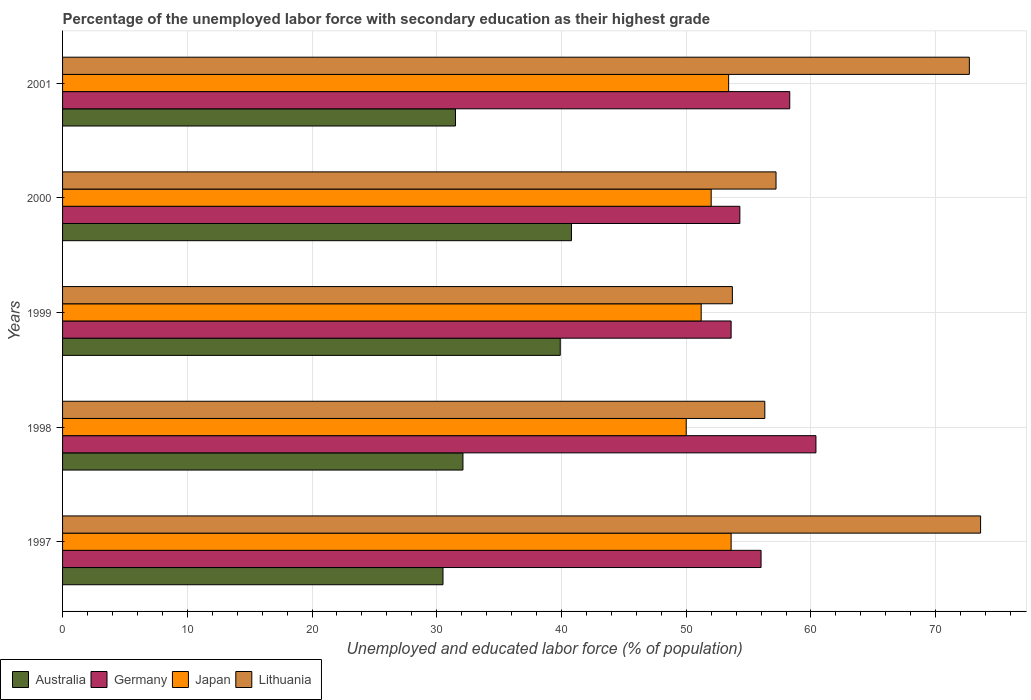How many different coloured bars are there?
Offer a very short reply. 4. How many groups of bars are there?
Keep it short and to the point. 5. Are the number of bars per tick equal to the number of legend labels?
Offer a terse response. Yes. How many bars are there on the 5th tick from the top?
Ensure brevity in your answer.  4. How many bars are there on the 4th tick from the bottom?
Provide a short and direct response. 4. What is the label of the 4th group of bars from the top?
Provide a succinct answer. 1998. In how many cases, is the number of bars for a given year not equal to the number of legend labels?
Keep it short and to the point. 0. What is the percentage of the unemployed labor force with secondary education in Germany in 1999?
Your answer should be compact. 53.6. Across all years, what is the maximum percentage of the unemployed labor force with secondary education in Germany?
Offer a terse response. 60.4. Across all years, what is the minimum percentage of the unemployed labor force with secondary education in Germany?
Your answer should be very brief. 53.6. In which year was the percentage of the unemployed labor force with secondary education in Japan minimum?
Your answer should be compact. 1998. What is the total percentage of the unemployed labor force with secondary education in Japan in the graph?
Your answer should be compact. 260.2. What is the difference between the percentage of the unemployed labor force with secondary education in Germany in 1997 and that in 2000?
Your response must be concise. 1.7. What is the difference between the percentage of the unemployed labor force with secondary education in Germany in 1998 and the percentage of the unemployed labor force with secondary education in Japan in 1999?
Make the answer very short. 9.2. What is the average percentage of the unemployed labor force with secondary education in Japan per year?
Give a very brief answer. 52.04. In the year 2001, what is the difference between the percentage of the unemployed labor force with secondary education in Japan and percentage of the unemployed labor force with secondary education in Lithuania?
Keep it short and to the point. -19.3. What is the ratio of the percentage of the unemployed labor force with secondary education in Japan in 1997 to that in 1998?
Your answer should be very brief. 1.07. Is the difference between the percentage of the unemployed labor force with secondary education in Japan in 1999 and 2001 greater than the difference between the percentage of the unemployed labor force with secondary education in Lithuania in 1999 and 2001?
Offer a terse response. Yes. What is the difference between the highest and the second highest percentage of the unemployed labor force with secondary education in Germany?
Give a very brief answer. 2.1. What is the difference between the highest and the lowest percentage of the unemployed labor force with secondary education in Japan?
Offer a very short reply. 3.6. Is it the case that in every year, the sum of the percentage of the unemployed labor force with secondary education in Japan and percentage of the unemployed labor force with secondary education in Germany is greater than the sum of percentage of the unemployed labor force with secondary education in Australia and percentage of the unemployed labor force with secondary education in Lithuania?
Offer a very short reply. No. What does the 3rd bar from the bottom in 2001 represents?
Ensure brevity in your answer.  Japan. How many bars are there?
Your response must be concise. 20. How many years are there in the graph?
Your answer should be very brief. 5. What is the difference between two consecutive major ticks on the X-axis?
Give a very brief answer. 10. Are the values on the major ticks of X-axis written in scientific E-notation?
Provide a short and direct response. No. Does the graph contain any zero values?
Offer a very short reply. No. Does the graph contain grids?
Offer a very short reply. Yes. How many legend labels are there?
Offer a very short reply. 4. How are the legend labels stacked?
Keep it short and to the point. Horizontal. What is the title of the graph?
Provide a short and direct response. Percentage of the unemployed labor force with secondary education as their highest grade. Does "Gabon" appear as one of the legend labels in the graph?
Provide a succinct answer. No. What is the label or title of the X-axis?
Offer a very short reply. Unemployed and educated labor force (% of population). What is the label or title of the Y-axis?
Your answer should be compact. Years. What is the Unemployed and educated labor force (% of population) of Australia in 1997?
Your answer should be compact. 30.5. What is the Unemployed and educated labor force (% of population) in Japan in 1997?
Provide a succinct answer. 53.6. What is the Unemployed and educated labor force (% of population) of Lithuania in 1997?
Ensure brevity in your answer.  73.6. What is the Unemployed and educated labor force (% of population) in Australia in 1998?
Your answer should be compact. 32.1. What is the Unemployed and educated labor force (% of population) in Germany in 1998?
Provide a succinct answer. 60.4. What is the Unemployed and educated labor force (% of population) in Japan in 1998?
Ensure brevity in your answer.  50. What is the Unemployed and educated labor force (% of population) in Lithuania in 1998?
Your answer should be very brief. 56.3. What is the Unemployed and educated labor force (% of population) of Australia in 1999?
Offer a very short reply. 39.9. What is the Unemployed and educated labor force (% of population) in Germany in 1999?
Your answer should be very brief. 53.6. What is the Unemployed and educated labor force (% of population) of Japan in 1999?
Your answer should be very brief. 51.2. What is the Unemployed and educated labor force (% of population) of Lithuania in 1999?
Offer a terse response. 53.7. What is the Unemployed and educated labor force (% of population) of Australia in 2000?
Offer a terse response. 40.8. What is the Unemployed and educated labor force (% of population) of Germany in 2000?
Offer a terse response. 54.3. What is the Unemployed and educated labor force (% of population) in Lithuania in 2000?
Make the answer very short. 57.2. What is the Unemployed and educated labor force (% of population) in Australia in 2001?
Ensure brevity in your answer.  31.5. What is the Unemployed and educated labor force (% of population) in Germany in 2001?
Offer a terse response. 58.3. What is the Unemployed and educated labor force (% of population) of Japan in 2001?
Provide a succinct answer. 53.4. What is the Unemployed and educated labor force (% of population) in Lithuania in 2001?
Ensure brevity in your answer.  72.7. Across all years, what is the maximum Unemployed and educated labor force (% of population) of Australia?
Your response must be concise. 40.8. Across all years, what is the maximum Unemployed and educated labor force (% of population) of Germany?
Provide a short and direct response. 60.4. Across all years, what is the maximum Unemployed and educated labor force (% of population) in Japan?
Offer a terse response. 53.6. Across all years, what is the maximum Unemployed and educated labor force (% of population) of Lithuania?
Offer a very short reply. 73.6. Across all years, what is the minimum Unemployed and educated labor force (% of population) of Australia?
Your answer should be compact. 30.5. Across all years, what is the minimum Unemployed and educated labor force (% of population) of Germany?
Give a very brief answer. 53.6. Across all years, what is the minimum Unemployed and educated labor force (% of population) in Lithuania?
Make the answer very short. 53.7. What is the total Unemployed and educated labor force (% of population) in Australia in the graph?
Offer a very short reply. 174.8. What is the total Unemployed and educated labor force (% of population) of Germany in the graph?
Keep it short and to the point. 282.6. What is the total Unemployed and educated labor force (% of population) in Japan in the graph?
Your answer should be compact. 260.2. What is the total Unemployed and educated labor force (% of population) of Lithuania in the graph?
Your answer should be compact. 313.5. What is the difference between the Unemployed and educated labor force (% of population) in Australia in 1997 and that in 1999?
Your answer should be compact. -9.4. What is the difference between the Unemployed and educated labor force (% of population) of Germany in 1997 and that in 1999?
Provide a short and direct response. 2.4. What is the difference between the Unemployed and educated labor force (% of population) in Lithuania in 1997 and that in 1999?
Your answer should be compact. 19.9. What is the difference between the Unemployed and educated labor force (% of population) of Germany in 1997 and that in 2000?
Your response must be concise. 1.7. What is the difference between the Unemployed and educated labor force (% of population) in Japan in 1997 and that in 2001?
Your response must be concise. 0.2. What is the difference between the Unemployed and educated labor force (% of population) of Australia in 1998 and that in 1999?
Offer a very short reply. -7.8. What is the difference between the Unemployed and educated labor force (% of population) of Germany in 1998 and that in 1999?
Offer a terse response. 6.8. What is the difference between the Unemployed and educated labor force (% of population) in Lithuania in 1998 and that in 1999?
Make the answer very short. 2.6. What is the difference between the Unemployed and educated labor force (% of population) of Germany in 1998 and that in 2000?
Provide a succinct answer. 6.1. What is the difference between the Unemployed and educated labor force (% of population) in Lithuania in 1998 and that in 2001?
Your response must be concise. -16.4. What is the difference between the Unemployed and educated labor force (% of population) of Germany in 1999 and that in 2000?
Offer a terse response. -0.7. What is the difference between the Unemployed and educated labor force (% of population) of Japan in 1999 and that in 2000?
Your response must be concise. -0.8. What is the difference between the Unemployed and educated labor force (% of population) of Lithuania in 1999 and that in 2000?
Offer a terse response. -3.5. What is the difference between the Unemployed and educated labor force (% of population) in Lithuania in 2000 and that in 2001?
Your response must be concise. -15.5. What is the difference between the Unemployed and educated labor force (% of population) in Australia in 1997 and the Unemployed and educated labor force (% of population) in Germany in 1998?
Provide a short and direct response. -29.9. What is the difference between the Unemployed and educated labor force (% of population) of Australia in 1997 and the Unemployed and educated labor force (% of population) of Japan in 1998?
Keep it short and to the point. -19.5. What is the difference between the Unemployed and educated labor force (% of population) of Australia in 1997 and the Unemployed and educated labor force (% of population) of Lithuania in 1998?
Your answer should be compact. -25.8. What is the difference between the Unemployed and educated labor force (% of population) of Germany in 1997 and the Unemployed and educated labor force (% of population) of Japan in 1998?
Your answer should be compact. 6. What is the difference between the Unemployed and educated labor force (% of population) of Germany in 1997 and the Unemployed and educated labor force (% of population) of Lithuania in 1998?
Ensure brevity in your answer.  -0.3. What is the difference between the Unemployed and educated labor force (% of population) in Australia in 1997 and the Unemployed and educated labor force (% of population) in Germany in 1999?
Offer a terse response. -23.1. What is the difference between the Unemployed and educated labor force (% of population) in Australia in 1997 and the Unemployed and educated labor force (% of population) in Japan in 1999?
Provide a short and direct response. -20.7. What is the difference between the Unemployed and educated labor force (% of population) in Australia in 1997 and the Unemployed and educated labor force (% of population) in Lithuania in 1999?
Keep it short and to the point. -23.2. What is the difference between the Unemployed and educated labor force (% of population) of Germany in 1997 and the Unemployed and educated labor force (% of population) of Japan in 1999?
Provide a succinct answer. 4.8. What is the difference between the Unemployed and educated labor force (% of population) of Germany in 1997 and the Unemployed and educated labor force (% of population) of Lithuania in 1999?
Offer a terse response. 2.3. What is the difference between the Unemployed and educated labor force (% of population) in Japan in 1997 and the Unemployed and educated labor force (% of population) in Lithuania in 1999?
Give a very brief answer. -0.1. What is the difference between the Unemployed and educated labor force (% of population) in Australia in 1997 and the Unemployed and educated labor force (% of population) in Germany in 2000?
Your answer should be compact. -23.8. What is the difference between the Unemployed and educated labor force (% of population) of Australia in 1997 and the Unemployed and educated labor force (% of population) of Japan in 2000?
Keep it short and to the point. -21.5. What is the difference between the Unemployed and educated labor force (% of population) in Australia in 1997 and the Unemployed and educated labor force (% of population) in Lithuania in 2000?
Your response must be concise. -26.7. What is the difference between the Unemployed and educated labor force (% of population) in Germany in 1997 and the Unemployed and educated labor force (% of population) in Japan in 2000?
Ensure brevity in your answer.  4. What is the difference between the Unemployed and educated labor force (% of population) in Japan in 1997 and the Unemployed and educated labor force (% of population) in Lithuania in 2000?
Give a very brief answer. -3.6. What is the difference between the Unemployed and educated labor force (% of population) of Australia in 1997 and the Unemployed and educated labor force (% of population) of Germany in 2001?
Give a very brief answer. -27.8. What is the difference between the Unemployed and educated labor force (% of population) in Australia in 1997 and the Unemployed and educated labor force (% of population) in Japan in 2001?
Your response must be concise. -22.9. What is the difference between the Unemployed and educated labor force (% of population) in Australia in 1997 and the Unemployed and educated labor force (% of population) in Lithuania in 2001?
Offer a terse response. -42.2. What is the difference between the Unemployed and educated labor force (% of population) of Germany in 1997 and the Unemployed and educated labor force (% of population) of Japan in 2001?
Your answer should be compact. 2.6. What is the difference between the Unemployed and educated labor force (% of population) in Germany in 1997 and the Unemployed and educated labor force (% of population) in Lithuania in 2001?
Your answer should be compact. -16.7. What is the difference between the Unemployed and educated labor force (% of population) in Japan in 1997 and the Unemployed and educated labor force (% of population) in Lithuania in 2001?
Provide a short and direct response. -19.1. What is the difference between the Unemployed and educated labor force (% of population) in Australia in 1998 and the Unemployed and educated labor force (% of population) in Germany in 1999?
Offer a very short reply. -21.5. What is the difference between the Unemployed and educated labor force (% of population) in Australia in 1998 and the Unemployed and educated labor force (% of population) in Japan in 1999?
Your answer should be compact. -19.1. What is the difference between the Unemployed and educated labor force (% of population) in Australia in 1998 and the Unemployed and educated labor force (% of population) in Lithuania in 1999?
Your answer should be compact. -21.6. What is the difference between the Unemployed and educated labor force (% of population) in Germany in 1998 and the Unemployed and educated labor force (% of population) in Japan in 1999?
Keep it short and to the point. 9.2. What is the difference between the Unemployed and educated labor force (% of population) in Germany in 1998 and the Unemployed and educated labor force (% of population) in Lithuania in 1999?
Offer a very short reply. 6.7. What is the difference between the Unemployed and educated labor force (% of population) of Australia in 1998 and the Unemployed and educated labor force (% of population) of Germany in 2000?
Keep it short and to the point. -22.2. What is the difference between the Unemployed and educated labor force (% of population) in Australia in 1998 and the Unemployed and educated labor force (% of population) in Japan in 2000?
Make the answer very short. -19.9. What is the difference between the Unemployed and educated labor force (% of population) of Australia in 1998 and the Unemployed and educated labor force (% of population) of Lithuania in 2000?
Your answer should be very brief. -25.1. What is the difference between the Unemployed and educated labor force (% of population) in Germany in 1998 and the Unemployed and educated labor force (% of population) in Lithuania in 2000?
Keep it short and to the point. 3.2. What is the difference between the Unemployed and educated labor force (% of population) in Australia in 1998 and the Unemployed and educated labor force (% of population) in Germany in 2001?
Offer a terse response. -26.2. What is the difference between the Unemployed and educated labor force (% of population) of Australia in 1998 and the Unemployed and educated labor force (% of population) of Japan in 2001?
Offer a very short reply. -21.3. What is the difference between the Unemployed and educated labor force (% of population) of Australia in 1998 and the Unemployed and educated labor force (% of population) of Lithuania in 2001?
Provide a succinct answer. -40.6. What is the difference between the Unemployed and educated labor force (% of population) in Japan in 1998 and the Unemployed and educated labor force (% of population) in Lithuania in 2001?
Provide a short and direct response. -22.7. What is the difference between the Unemployed and educated labor force (% of population) in Australia in 1999 and the Unemployed and educated labor force (% of population) in Germany in 2000?
Ensure brevity in your answer.  -14.4. What is the difference between the Unemployed and educated labor force (% of population) of Australia in 1999 and the Unemployed and educated labor force (% of population) of Japan in 2000?
Make the answer very short. -12.1. What is the difference between the Unemployed and educated labor force (% of population) of Australia in 1999 and the Unemployed and educated labor force (% of population) of Lithuania in 2000?
Provide a short and direct response. -17.3. What is the difference between the Unemployed and educated labor force (% of population) in Germany in 1999 and the Unemployed and educated labor force (% of population) in Japan in 2000?
Keep it short and to the point. 1.6. What is the difference between the Unemployed and educated labor force (% of population) of Germany in 1999 and the Unemployed and educated labor force (% of population) of Lithuania in 2000?
Your answer should be compact. -3.6. What is the difference between the Unemployed and educated labor force (% of population) of Japan in 1999 and the Unemployed and educated labor force (% of population) of Lithuania in 2000?
Make the answer very short. -6. What is the difference between the Unemployed and educated labor force (% of population) in Australia in 1999 and the Unemployed and educated labor force (% of population) in Germany in 2001?
Provide a short and direct response. -18.4. What is the difference between the Unemployed and educated labor force (% of population) in Australia in 1999 and the Unemployed and educated labor force (% of population) in Japan in 2001?
Ensure brevity in your answer.  -13.5. What is the difference between the Unemployed and educated labor force (% of population) of Australia in 1999 and the Unemployed and educated labor force (% of population) of Lithuania in 2001?
Provide a succinct answer. -32.8. What is the difference between the Unemployed and educated labor force (% of population) of Germany in 1999 and the Unemployed and educated labor force (% of population) of Lithuania in 2001?
Keep it short and to the point. -19.1. What is the difference between the Unemployed and educated labor force (% of population) of Japan in 1999 and the Unemployed and educated labor force (% of population) of Lithuania in 2001?
Make the answer very short. -21.5. What is the difference between the Unemployed and educated labor force (% of population) in Australia in 2000 and the Unemployed and educated labor force (% of population) in Germany in 2001?
Your answer should be very brief. -17.5. What is the difference between the Unemployed and educated labor force (% of population) of Australia in 2000 and the Unemployed and educated labor force (% of population) of Lithuania in 2001?
Provide a short and direct response. -31.9. What is the difference between the Unemployed and educated labor force (% of population) of Germany in 2000 and the Unemployed and educated labor force (% of population) of Japan in 2001?
Your answer should be compact. 0.9. What is the difference between the Unemployed and educated labor force (% of population) of Germany in 2000 and the Unemployed and educated labor force (% of population) of Lithuania in 2001?
Make the answer very short. -18.4. What is the difference between the Unemployed and educated labor force (% of population) of Japan in 2000 and the Unemployed and educated labor force (% of population) of Lithuania in 2001?
Your answer should be compact. -20.7. What is the average Unemployed and educated labor force (% of population) in Australia per year?
Offer a terse response. 34.96. What is the average Unemployed and educated labor force (% of population) in Germany per year?
Your response must be concise. 56.52. What is the average Unemployed and educated labor force (% of population) in Japan per year?
Offer a terse response. 52.04. What is the average Unemployed and educated labor force (% of population) of Lithuania per year?
Your answer should be compact. 62.7. In the year 1997, what is the difference between the Unemployed and educated labor force (% of population) in Australia and Unemployed and educated labor force (% of population) in Germany?
Offer a very short reply. -25.5. In the year 1997, what is the difference between the Unemployed and educated labor force (% of population) in Australia and Unemployed and educated labor force (% of population) in Japan?
Offer a very short reply. -23.1. In the year 1997, what is the difference between the Unemployed and educated labor force (% of population) of Australia and Unemployed and educated labor force (% of population) of Lithuania?
Your response must be concise. -43.1. In the year 1997, what is the difference between the Unemployed and educated labor force (% of population) of Germany and Unemployed and educated labor force (% of population) of Japan?
Give a very brief answer. 2.4. In the year 1997, what is the difference between the Unemployed and educated labor force (% of population) in Germany and Unemployed and educated labor force (% of population) in Lithuania?
Keep it short and to the point. -17.6. In the year 1997, what is the difference between the Unemployed and educated labor force (% of population) of Japan and Unemployed and educated labor force (% of population) of Lithuania?
Offer a very short reply. -20. In the year 1998, what is the difference between the Unemployed and educated labor force (% of population) of Australia and Unemployed and educated labor force (% of population) of Germany?
Offer a very short reply. -28.3. In the year 1998, what is the difference between the Unemployed and educated labor force (% of population) in Australia and Unemployed and educated labor force (% of population) in Japan?
Provide a succinct answer. -17.9. In the year 1998, what is the difference between the Unemployed and educated labor force (% of population) in Australia and Unemployed and educated labor force (% of population) in Lithuania?
Provide a short and direct response. -24.2. In the year 1998, what is the difference between the Unemployed and educated labor force (% of population) of Japan and Unemployed and educated labor force (% of population) of Lithuania?
Give a very brief answer. -6.3. In the year 1999, what is the difference between the Unemployed and educated labor force (% of population) of Australia and Unemployed and educated labor force (% of population) of Germany?
Offer a very short reply. -13.7. In the year 1999, what is the difference between the Unemployed and educated labor force (% of population) in Australia and Unemployed and educated labor force (% of population) in Japan?
Provide a succinct answer. -11.3. In the year 1999, what is the difference between the Unemployed and educated labor force (% of population) in Germany and Unemployed and educated labor force (% of population) in Lithuania?
Provide a short and direct response. -0.1. In the year 1999, what is the difference between the Unemployed and educated labor force (% of population) in Japan and Unemployed and educated labor force (% of population) in Lithuania?
Offer a very short reply. -2.5. In the year 2000, what is the difference between the Unemployed and educated labor force (% of population) of Australia and Unemployed and educated labor force (% of population) of Germany?
Ensure brevity in your answer.  -13.5. In the year 2000, what is the difference between the Unemployed and educated labor force (% of population) in Australia and Unemployed and educated labor force (% of population) in Lithuania?
Offer a very short reply. -16.4. In the year 2000, what is the difference between the Unemployed and educated labor force (% of population) in Japan and Unemployed and educated labor force (% of population) in Lithuania?
Offer a terse response. -5.2. In the year 2001, what is the difference between the Unemployed and educated labor force (% of population) of Australia and Unemployed and educated labor force (% of population) of Germany?
Your answer should be compact. -26.8. In the year 2001, what is the difference between the Unemployed and educated labor force (% of population) of Australia and Unemployed and educated labor force (% of population) of Japan?
Provide a succinct answer. -21.9. In the year 2001, what is the difference between the Unemployed and educated labor force (% of population) in Australia and Unemployed and educated labor force (% of population) in Lithuania?
Make the answer very short. -41.2. In the year 2001, what is the difference between the Unemployed and educated labor force (% of population) in Germany and Unemployed and educated labor force (% of population) in Lithuania?
Your answer should be compact. -14.4. In the year 2001, what is the difference between the Unemployed and educated labor force (% of population) of Japan and Unemployed and educated labor force (% of population) of Lithuania?
Provide a short and direct response. -19.3. What is the ratio of the Unemployed and educated labor force (% of population) of Australia in 1997 to that in 1998?
Your answer should be compact. 0.95. What is the ratio of the Unemployed and educated labor force (% of population) of Germany in 1997 to that in 1998?
Ensure brevity in your answer.  0.93. What is the ratio of the Unemployed and educated labor force (% of population) of Japan in 1997 to that in 1998?
Provide a short and direct response. 1.07. What is the ratio of the Unemployed and educated labor force (% of population) in Lithuania in 1997 to that in 1998?
Give a very brief answer. 1.31. What is the ratio of the Unemployed and educated labor force (% of population) of Australia in 1997 to that in 1999?
Your answer should be compact. 0.76. What is the ratio of the Unemployed and educated labor force (% of population) of Germany in 1997 to that in 1999?
Make the answer very short. 1.04. What is the ratio of the Unemployed and educated labor force (% of population) of Japan in 1997 to that in 1999?
Provide a short and direct response. 1.05. What is the ratio of the Unemployed and educated labor force (% of population) of Lithuania in 1997 to that in 1999?
Ensure brevity in your answer.  1.37. What is the ratio of the Unemployed and educated labor force (% of population) of Australia in 1997 to that in 2000?
Ensure brevity in your answer.  0.75. What is the ratio of the Unemployed and educated labor force (% of population) in Germany in 1997 to that in 2000?
Ensure brevity in your answer.  1.03. What is the ratio of the Unemployed and educated labor force (% of population) of Japan in 1997 to that in 2000?
Ensure brevity in your answer.  1.03. What is the ratio of the Unemployed and educated labor force (% of population) of Lithuania in 1997 to that in 2000?
Your response must be concise. 1.29. What is the ratio of the Unemployed and educated labor force (% of population) in Australia in 1997 to that in 2001?
Make the answer very short. 0.97. What is the ratio of the Unemployed and educated labor force (% of population) of Germany in 1997 to that in 2001?
Offer a very short reply. 0.96. What is the ratio of the Unemployed and educated labor force (% of population) of Lithuania in 1997 to that in 2001?
Offer a terse response. 1.01. What is the ratio of the Unemployed and educated labor force (% of population) of Australia in 1998 to that in 1999?
Offer a terse response. 0.8. What is the ratio of the Unemployed and educated labor force (% of population) of Germany in 1998 to that in 1999?
Your answer should be very brief. 1.13. What is the ratio of the Unemployed and educated labor force (% of population) of Japan in 1998 to that in 1999?
Keep it short and to the point. 0.98. What is the ratio of the Unemployed and educated labor force (% of population) of Lithuania in 1998 to that in 1999?
Your response must be concise. 1.05. What is the ratio of the Unemployed and educated labor force (% of population) of Australia in 1998 to that in 2000?
Provide a succinct answer. 0.79. What is the ratio of the Unemployed and educated labor force (% of population) in Germany in 1998 to that in 2000?
Your response must be concise. 1.11. What is the ratio of the Unemployed and educated labor force (% of population) of Japan in 1998 to that in 2000?
Make the answer very short. 0.96. What is the ratio of the Unemployed and educated labor force (% of population) in Lithuania in 1998 to that in 2000?
Give a very brief answer. 0.98. What is the ratio of the Unemployed and educated labor force (% of population) in Germany in 1998 to that in 2001?
Provide a succinct answer. 1.04. What is the ratio of the Unemployed and educated labor force (% of population) in Japan in 1998 to that in 2001?
Keep it short and to the point. 0.94. What is the ratio of the Unemployed and educated labor force (% of population) of Lithuania in 1998 to that in 2001?
Offer a very short reply. 0.77. What is the ratio of the Unemployed and educated labor force (% of population) in Australia in 1999 to that in 2000?
Make the answer very short. 0.98. What is the ratio of the Unemployed and educated labor force (% of population) of Germany in 1999 to that in 2000?
Offer a terse response. 0.99. What is the ratio of the Unemployed and educated labor force (% of population) of Japan in 1999 to that in 2000?
Offer a terse response. 0.98. What is the ratio of the Unemployed and educated labor force (% of population) in Lithuania in 1999 to that in 2000?
Give a very brief answer. 0.94. What is the ratio of the Unemployed and educated labor force (% of population) in Australia in 1999 to that in 2001?
Give a very brief answer. 1.27. What is the ratio of the Unemployed and educated labor force (% of population) in Germany in 1999 to that in 2001?
Offer a terse response. 0.92. What is the ratio of the Unemployed and educated labor force (% of population) in Japan in 1999 to that in 2001?
Your answer should be compact. 0.96. What is the ratio of the Unemployed and educated labor force (% of population) of Lithuania in 1999 to that in 2001?
Offer a terse response. 0.74. What is the ratio of the Unemployed and educated labor force (% of population) of Australia in 2000 to that in 2001?
Your answer should be compact. 1.3. What is the ratio of the Unemployed and educated labor force (% of population) in Germany in 2000 to that in 2001?
Ensure brevity in your answer.  0.93. What is the ratio of the Unemployed and educated labor force (% of population) in Japan in 2000 to that in 2001?
Offer a terse response. 0.97. What is the ratio of the Unemployed and educated labor force (% of population) of Lithuania in 2000 to that in 2001?
Ensure brevity in your answer.  0.79. What is the difference between the highest and the second highest Unemployed and educated labor force (% of population) of Japan?
Your answer should be compact. 0.2. What is the difference between the highest and the second highest Unemployed and educated labor force (% of population) of Lithuania?
Your answer should be very brief. 0.9. What is the difference between the highest and the lowest Unemployed and educated labor force (% of population) of Germany?
Your answer should be very brief. 6.8. What is the difference between the highest and the lowest Unemployed and educated labor force (% of population) of Japan?
Make the answer very short. 3.6. 